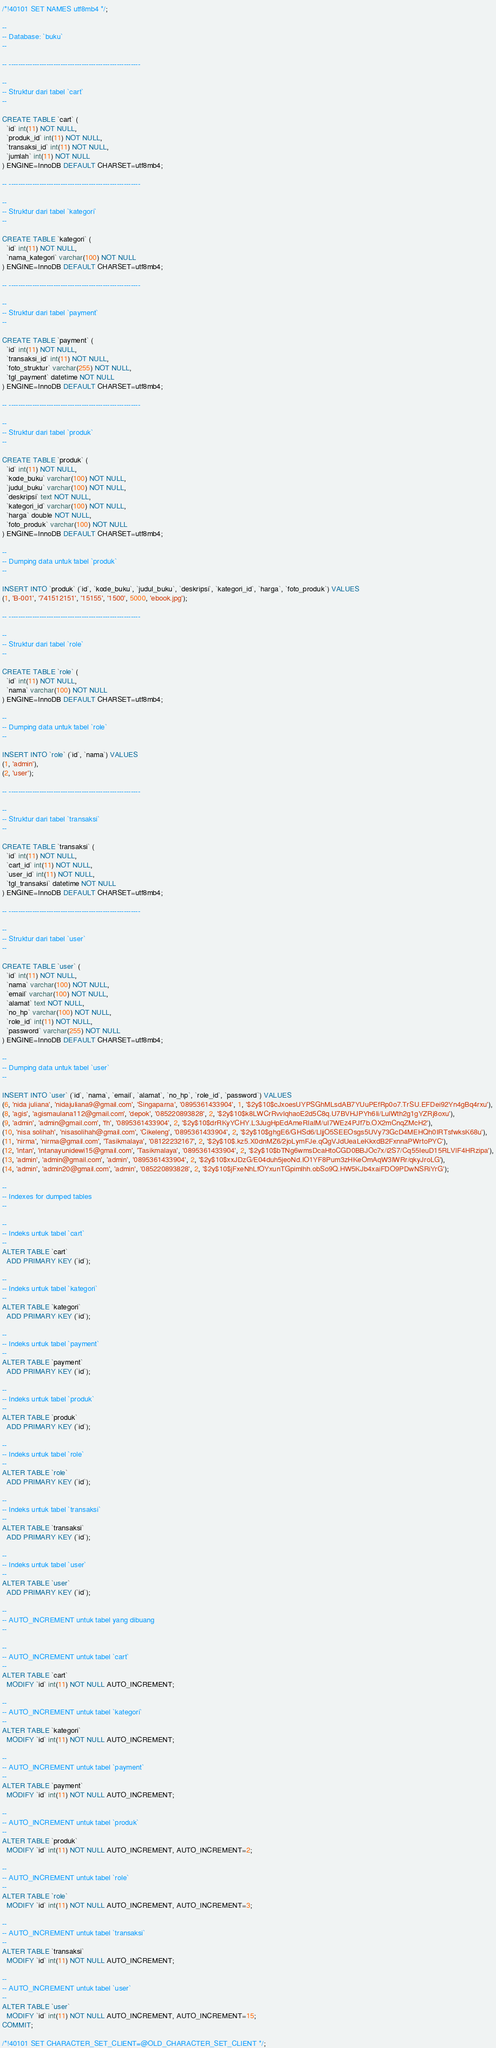<code> <loc_0><loc_0><loc_500><loc_500><_SQL_>/*!40101 SET NAMES utf8mb4 */;

--
-- Database: `buku`
--

-- --------------------------------------------------------

--
-- Struktur dari tabel `cart`
--

CREATE TABLE `cart` (
  `id` int(11) NOT NULL,
  `produk_id` int(11) NOT NULL,
  `transaksi_id` int(11) NOT NULL,
  `jumlah` int(11) NOT NULL
) ENGINE=InnoDB DEFAULT CHARSET=utf8mb4;

-- --------------------------------------------------------

--
-- Struktur dari tabel `kategori`
--

CREATE TABLE `kategori` (
  `id` int(11) NOT NULL,
  `nama_kategori` varchar(100) NOT NULL
) ENGINE=InnoDB DEFAULT CHARSET=utf8mb4;

-- --------------------------------------------------------

--
-- Struktur dari tabel `payment`
--

CREATE TABLE `payment` (
  `id` int(11) NOT NULL,
  `transaksi_id` int(11) NOT NULL,
  `foto_struktur` varchar(255) NOT NULL,
  `tgl_payment` datetime NOT NULL
) ENGINE=InnoDB DEFAULT CHARSET=utf8mb4;

-- --------------------------------------------------------

--
-- Struktur dari tabel `produk`
--

CREATE TABLE `produk` (
  `id` int(11) NOT NULL,
  `kode_buku` varchar(100) NOT NULL,
  `judul_buku` varchar(100) NOT NULL,
  `deskripsi` text NOT NULL,
  `kategori_id` varchar(100) NOT NULL,
  `harga` double NOT NULL,
  `foto_produk` varchar(100) NOT NULL
) ENGINE=InnoDB DEFAULT CHARSET=utf8mb4;

--
-- Dumping data untuk tabel `produk`
--

INSERT INTO `produk` (`id`, `kode_buku`, `judul_buku`, `deskripsi`, `kategori_id`, `harga`, `foto_produk`) VALUES
(1, 'B-001', '741512151', '15155', '1500', 5000, 'ebook.jpg');

-- --------------------------------------------------------

--
-- Struktur dari tabel `role`
--

CREATE TABLE `role` (
  `id` int(11) NOT NULL,
  `nama` varchar(100) NOT NULL
) ENGINE=InnoDB DEFAULT CHARSET=utf8mb4;

--
-- Dumping data untuk tabel `role`
--

INSERT INTO `role` (`id`, `nama`) VALUES
(1, 'admin'),
(2, 'user');

-- --------------------------------------------------------

--
-- Struktur dari tabel `transaksi`
--

CREATE TABLE `transaksi` (
  `id` int(11) NOT NULL,
  `cart_id` int(11) NOT NULL,
  `user_id` int(11) NOT NULL,
  `tgl_transaksi` datetime NOT NULL
) ENGINE=InnoDB DEFAULT CHARSET=utf8mb4;

-- --------------------------------------------------------

--
-- Struktur dari tabel `user`
--

CREATE TABLE `user` (
  `id` int(11) NOT NULL,
  `nama` varchar(100) NOT NULL,
  `email` varchar(100) NOT NULL,
  `alamat` text NOT NULL,
  `no_hp` varchar(100) NOT NULL,
  `role_id` int(11) NOT NULL,
  `password` varchar(255) NOT NULL
) ENGINE=InnoDB DEFAULT CHARSET=utf8mb4;

--
-- Dumping data untuk tabel `user`
--

INSERT INTO `user` (`id`, `nama`, `email`, `alamat`, `no_hp`, `role_id`, `password`) VALUES
(6, 'nida juliana', 'nidajuliana9@gmail.com', 'Singaparna', '0895361433904', 1, '$2y$10$cJxoesUYPSGhMLsdAB7YUuPEfRp0o7.TrSU.EFDei92Yn4gBq4rxu'),
(8, 'agis', 'agismaulana112@gmail.com', 'depok', '085220893828', 2, '$2y$10$k8LWCrRvvlqhaoE2d5C8q.U7BVHJPYh6Ii/LulWth2g1gYZRj8oxu'),
(9, 'admin', 'admin@gmail.com', 'fh', '0895361433904', 2, '$2y$10$drRKyYCHY.L3JugHpEdAmeRIaIM/uI7WEz4PJf7b.OX2mCnqZMcH2'),
(10, 'nisa solihah', 'nisasolihah@gmail.com', 'Cikeleng', '0895361433904', 2, '$2y$10$ghgE6/GHSd6/LljjO5SEEOsgs5UVy73GcD4MEHQh0IRTsfwksK68u'),
(11, 'nirma', 'nirma@gmail.com', 'Tasikmalaya', '08122232167', 2, '$2y$10$.kz5.X0dnMZ6/2joLymFJe.qQgVJdUeaLeKkxdB2FxnnaPWrtoPYC'),
(12, 'intan', 'intanayunidewi15@gmail.com', 'Tasikmalaya', '0895361433904', 2, '$2y$10$bTNg6wmsDcaHtoCGD0BBJOc7x/i2S7/Cq55IeuD15RLVlF4HRzipa'),
(13, 'admin', 'admin@gmail.com', 'admin', '0895361433904', 2, '$2y$10$xxJDzG/E04duh5jeoNd.IO1YF8Pum3zHKeOmAqW3lWRr/qkyJroLG'),
(14, 'admin', 'admin20@gmail.com', 'admin', '085220893828', 2, '$2y$10$jFxeNhLfOYxunTGpimlhh.obSo9Q.HW5KJb4xaiFDO9PDwNSRiYrG');

--
-- Indexes for dumped tables
--

--
-- Indeks untuk tabel `cart`
--
ALTER TABLE `cart`
  ADD PRIMARY KEY (`id`);

--
-- Indeks untuk tabel `kategori`
--
ALTER TABLE `kategori`
  ADD PRIMARY KEY (`id`);

--
-- Indeks untuk tabel `payment`
--
ALTER TABLE `payment`
  ADD PRIMARY KEY (`id`);

--
-- Indeks untuk tabel `produk`
--
ALTER TABLE `produk`
  ADD PRIMARY KEY (`id`);

--
-- Indeks untuk tabel `role`
--
ALTER TABLE `role`
  ADD PRIMARY KEY (`id`);

--
-- Indeks untuk tabel `transaksi`
--
ALTER TABLE `transaksi`
  ADD PRIMARY KEY (`id`);

--
-- Indeks untuk tabel `user`
--
ALTER TABLE `user`
  ADD PRIMARY KEY (`id`);

--
-- AUTO_INCREMENT untuk tabel yang dibuang
--

--
-- AUTO_INCREMENT untuk tabel `cart`
--
ALTER TABLE `cart`
  MODIFY `id` int(11) NOT NULL AUTO_INCREMENT;

--
-- AUTO_INCREMENT untuk tabel `kategori`
--
ALTER TABLE `kategori`
  MODIFY `id` int(11) NOT NULL AUTO_INCREMENT;

--
-- AUTO_INCREMENT untuk tabel `payment`
--
ALTER TABLE `payment`
  MODIFY `id` int(11) NOT NULL AUTO_INCREMENT;

--
-- AUTO_INCREMENT untuk tabel `produk`
--
ALTER TABLE `produk`
  MODIFY `id` int(11) NOT NULL AUTO_INCREMENT, AUTO_INCREMENT=2;

--
-- AUTO_INCREMENT untuk tabel `role`
--
ALTER TABLE `role`
  MODIFY `id` int(11) NOT NULL AUTO_INCREMENT, AUTO_INCREMENT=3;

--
-- AUTO_INCREMENT untuk tabel `transaksi`
--
ALTER TABLE `transaksi`
  MODIFY `id` int(11) NOT NULL AUTO_INCREMENT;

--
-- AUTO_INCREMENT untuk tabel `user`
--
ALTER TABLE `user`
  MODIFY `id` int(11) NOT NULL AUTO_INCREMENT, AUTO_INCREMENT=15;
COMMIT;

/*!40101 SET CHARACTER_SET_CLIENT=@OLD_CHARACTER_SET_CLIENT */;</code> 